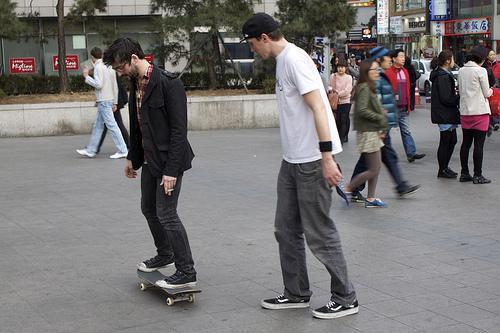How many people are on skateboards?
Give a very brief answer. 1. 